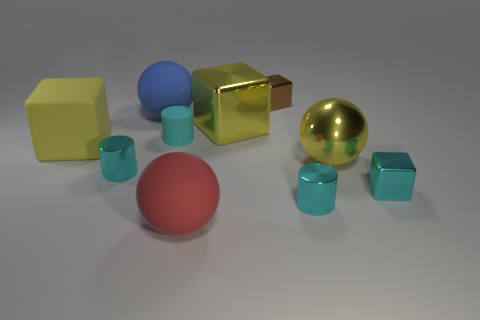There is a big thing that is the same material as the yellow sphere; what shape is it?
Make the answer very short. Cube. What is the color of the rubber cube that is the same size as the red rubber sphere?
Provide a succinct answer. Yellow. Does the cyan metallic cylinder right of the brown object have the same size as the large red ball?
Provide a short and direct response. No. Is the tiny matte object the same color as the big matte block?
Make the answer very short. No. How many tiny blue rubber blocks are there?
Make the answer very short. 0. What number of cylinders are large purple things or large things?
Ensure brevity in your answer.  0. What number of small cyan rubber cylinders are to the left of the large metallic thing that is in front of the big yellow matte cube?
Keep it short and to the point. 1. Do the large blue object and the large red object have the same material?
Ensure brevity in your answer.  Yes. The metallic sphere that is the same color as the rubber block is what size?
Make the answer very short. Large. Is there a brown cube made of the same material as the big yellow ball?
Give a very brief answer. Yes. 